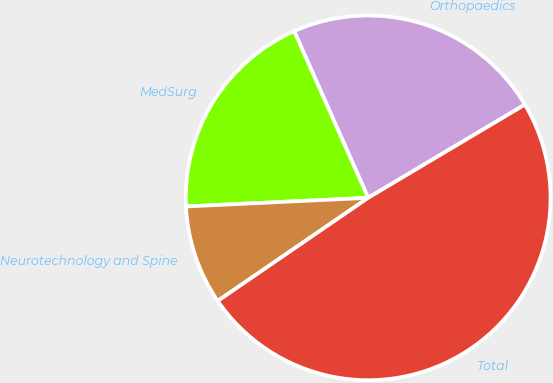<chart> <loc_0><loc_0><loc_500><loc_500><pie_chart><fcel>Orthopaedics<fcel>MedSurg<fcel>Neurotechnology and Spine<fcel>Total<nl><fcel>23.11%<fcel>19.1%<fcel>8.81%<fcel>48.97%<nl></chart> 